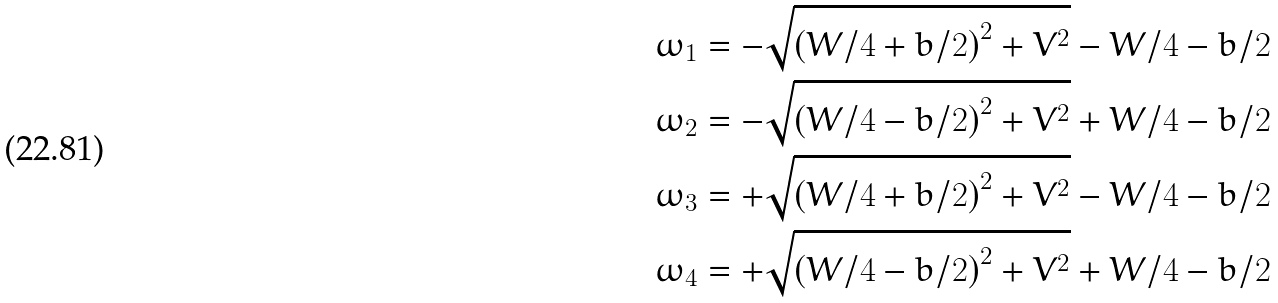<formula> <loc_0><loc_0><loc_500><loc_500>\omega _ { 1 } & = - \sqrt { \left ( W / 4 + b / 2 \right ) ^ { 2 } + V ^ { 2 } } - W / 4 - b / 2 \\ \omega _ { 2 } & = - \sqrt { \left ( W / 4 - b / 2 \right ) ^ { 2 } + V ^ { 2 } } + W / 4 - b / 2 \\ \omega _ { 3 } & = + \sqrt { \left ( W / 4 + b / 2 \right ) ^ { 2 } + V ^ { 2 } } - W / 4 - b / 2 \\ \omega _ { 4 } & = + \sqrt { \left ( W / 4 - b / 2 \right ) ^ { 2 } + V ^ { 2 } } + W / 4 - b / 2</formula> 